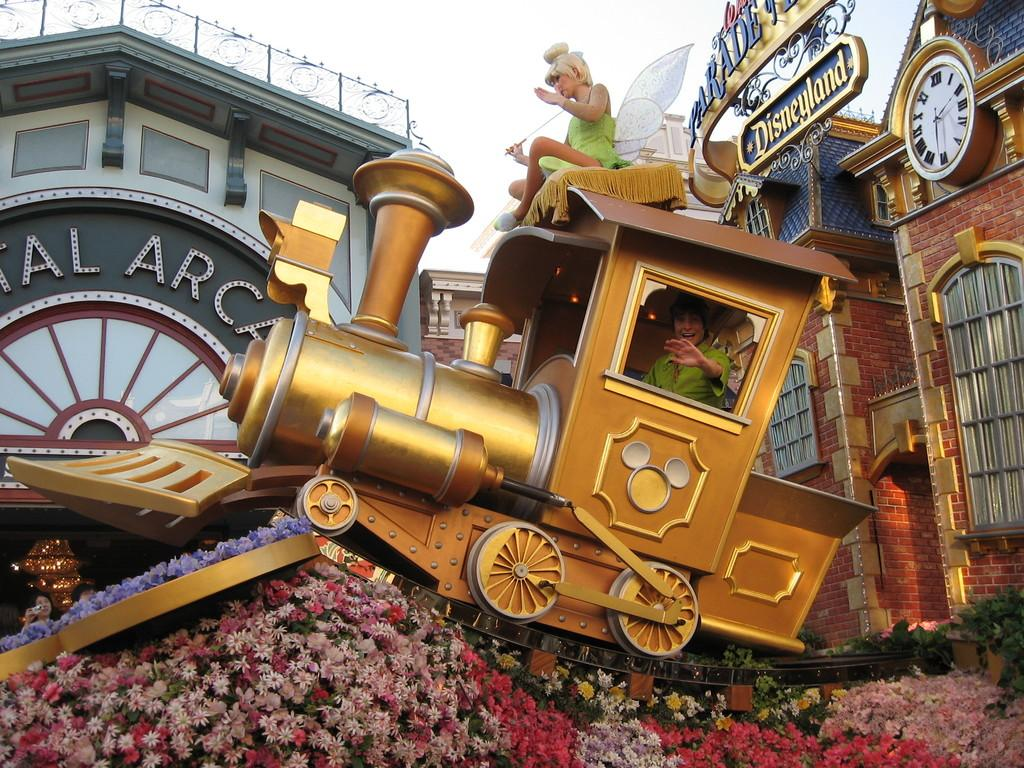Provide a one-sentence caption for the provided image. a Disneyland Peter Pan train with someone inside it. 